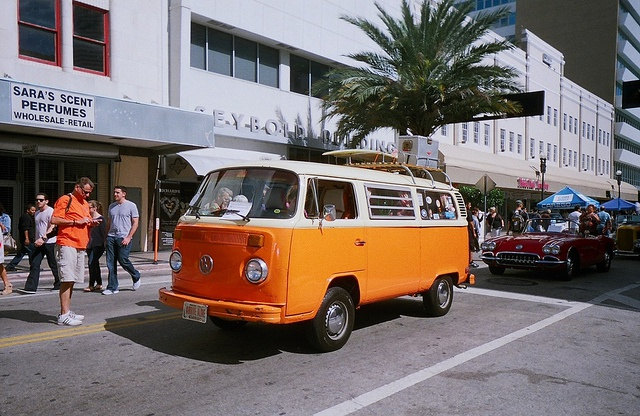Describe the objects in this image and their specific colors. I can see bus in lightgray, orange, black, and maroon tones, car in lightgray, orange, black, and maroon tones, car in lightgray, black, maroon, gray, and darkgray tones, people in lightgray, darkgray, maroon, red, and salmon tones, and people in lightgray, black, gray, darkgray, and maroon tones in this image. 